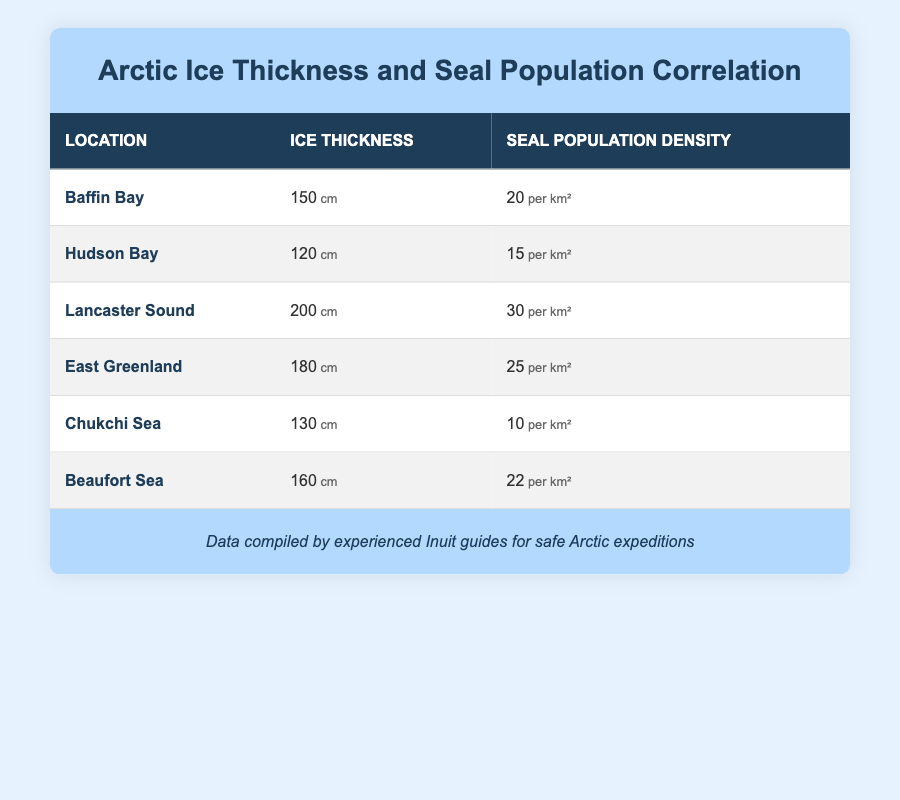What is the ice thickness in Lancaster Sound? The table has a row for Lancaster Sound indicating that the ice thickness is 200 cm.
Answer: 200 cm How many seal population density per square kilometer are found in East Greenland? According to the East Greenland row in the table, the seal population density is 25 per km².
Answer: 25 per km² What is the total ice thickness of all locations listed in the table? The individual ice thickness values are 150, 120, 200, 180, 130, and 160 cm. Adding them together gives 150 + 120 + 200 + 180 + 130 + 160 = 1,040 cm.
Answer: 1,040 cm Is the seal population density higher in Baffin Bay compared to Chukchi Sea? Baffin Bay has a seal population density of 20 per km², whereas Chukchi Sea shows 10 per km². Since 20 is greater than 10, the statement is true.
Answer: Yes What is the average ice thickness among all the locations? The ice thickness values are 150, 120, 200, 180, 130, and 160 cm. The total is 1,040 cm and there are 6 locations, so the average is 1,040/6 ≈ 173.33 cm.
Answer: 173.33 cm Which location has the highest seal population density? Looking at the numbers in the seal population density column, Lancaster Sound has the highest value at 30 per km².
Answer: Lancaster Sound What is the difference in seal population density between Baffin Bay and Hudson Bay? Baffin Bay has a density of 20 per km² and Hudson Bay has a density of 15 per km². The difference is 20 - 15 = 5 per km².
Answer: 5 per km² Is the ice thickness in Hudson Bay greater than in Beaufort Sea? Hudson Bay has an ice thickness of 120 cm while Beaufort Sea shows 160 cm. Since 120 is less than 160, the statement is false.
Answer: No Which location shows a seal population density of more than 20 per km²? By examining the seal population density values, Lancaster Sound (30 per km²) and East Greenland (25 per km²) are both above 20 per km².
Answer: Lancaster Sound and East Greenland 